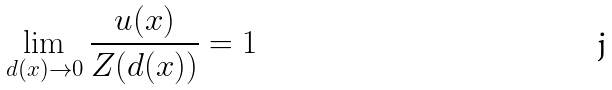Convert formula to latex. <formula><loc_0><loc_0><loc_500><loc_500>\lim _ { d ( x ) \to 0 } \frac { u ( x ) } { Z ( d ( x ) ) } = 1</formula> 